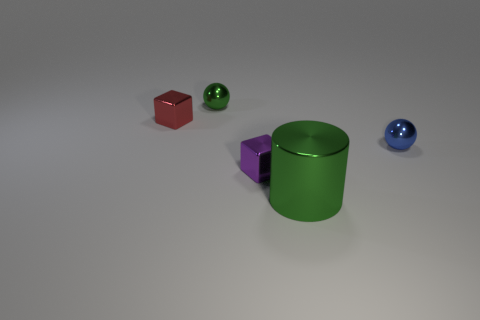Subtract all purple blocks. How many blocks are left? 1 Add 3 tiny cyan cylinders. How many objects exist? 8 Subtract all cubes. How many objects are left? 3 Add 3 blue metallic balls. How many blue metallic balls are left? 4 Add 5 tiny blue shiny objects. How many tiny blue shiny objects exist? 6 Subtract 1 green cylinders. How many objects are left? 4 Subtract all cyan cubes. Subtract all green spheres. How many cubes are left? 2 Subtract all red metal objects. Subtract all small purple metal things. How many objects are left? 3 